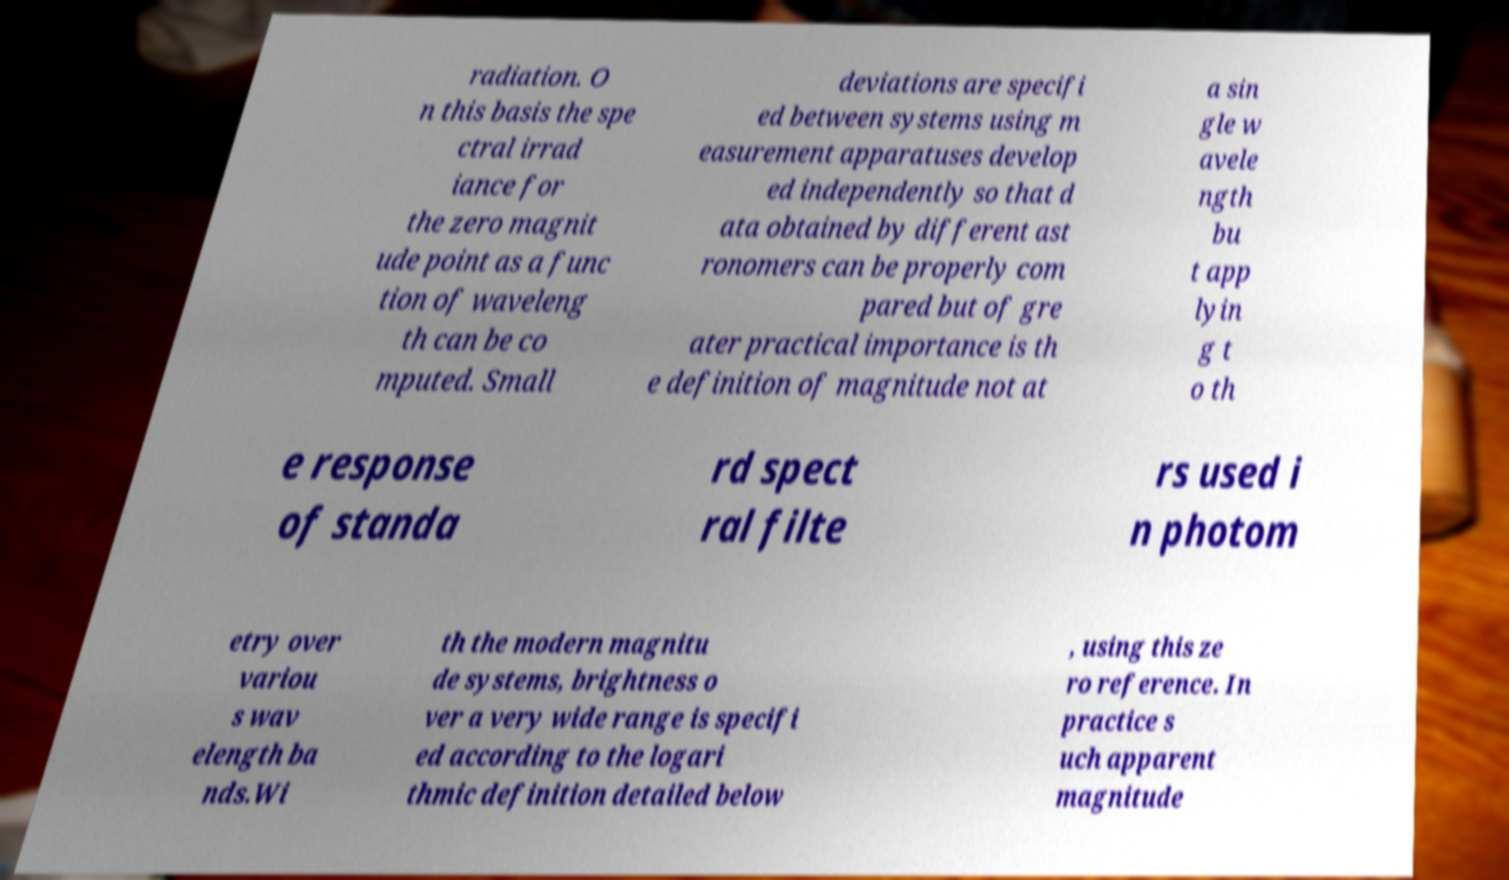Can you accurately transcribe the text from the provided image for me? radiation. O n this basis the spe ctral irrad iance for the zero magnit ude point as a func tion of waveleng th can be co mputed. Small deviations are specifi ed between systems using m easurement apparatuses develop ed independently so that d ata obtained by different ast ronomers can be properly com pared but of gre ater practical importance is th e definition of magnitude not at a sin gle w avele ngth bu t app lyin g t o th e response of standa rd spect ral filte rs used i n photom etry over variou s wav elength ba nds.Wi th the modern magnitu de systems, brightness o ver a very wide range is specifi ed according to the logari thmic definition detailed below , using this ze ro reference. In practice s uch apparent magnitude 